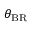<formula> <loc_0><loc_0><loc_500><loc_500>\theta _ { B R }</formula> 